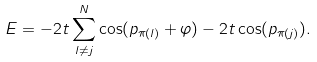<formula> <loc_0><loc_0><loc_500><loc_500>E = - 2 t \sum _ { l \neq j } ^ { N } \cos ( p _ { \pi ( l ) } + \varphi ) - 2 t \cos ( p _ { \pi ( j ) } ) .</formula> 